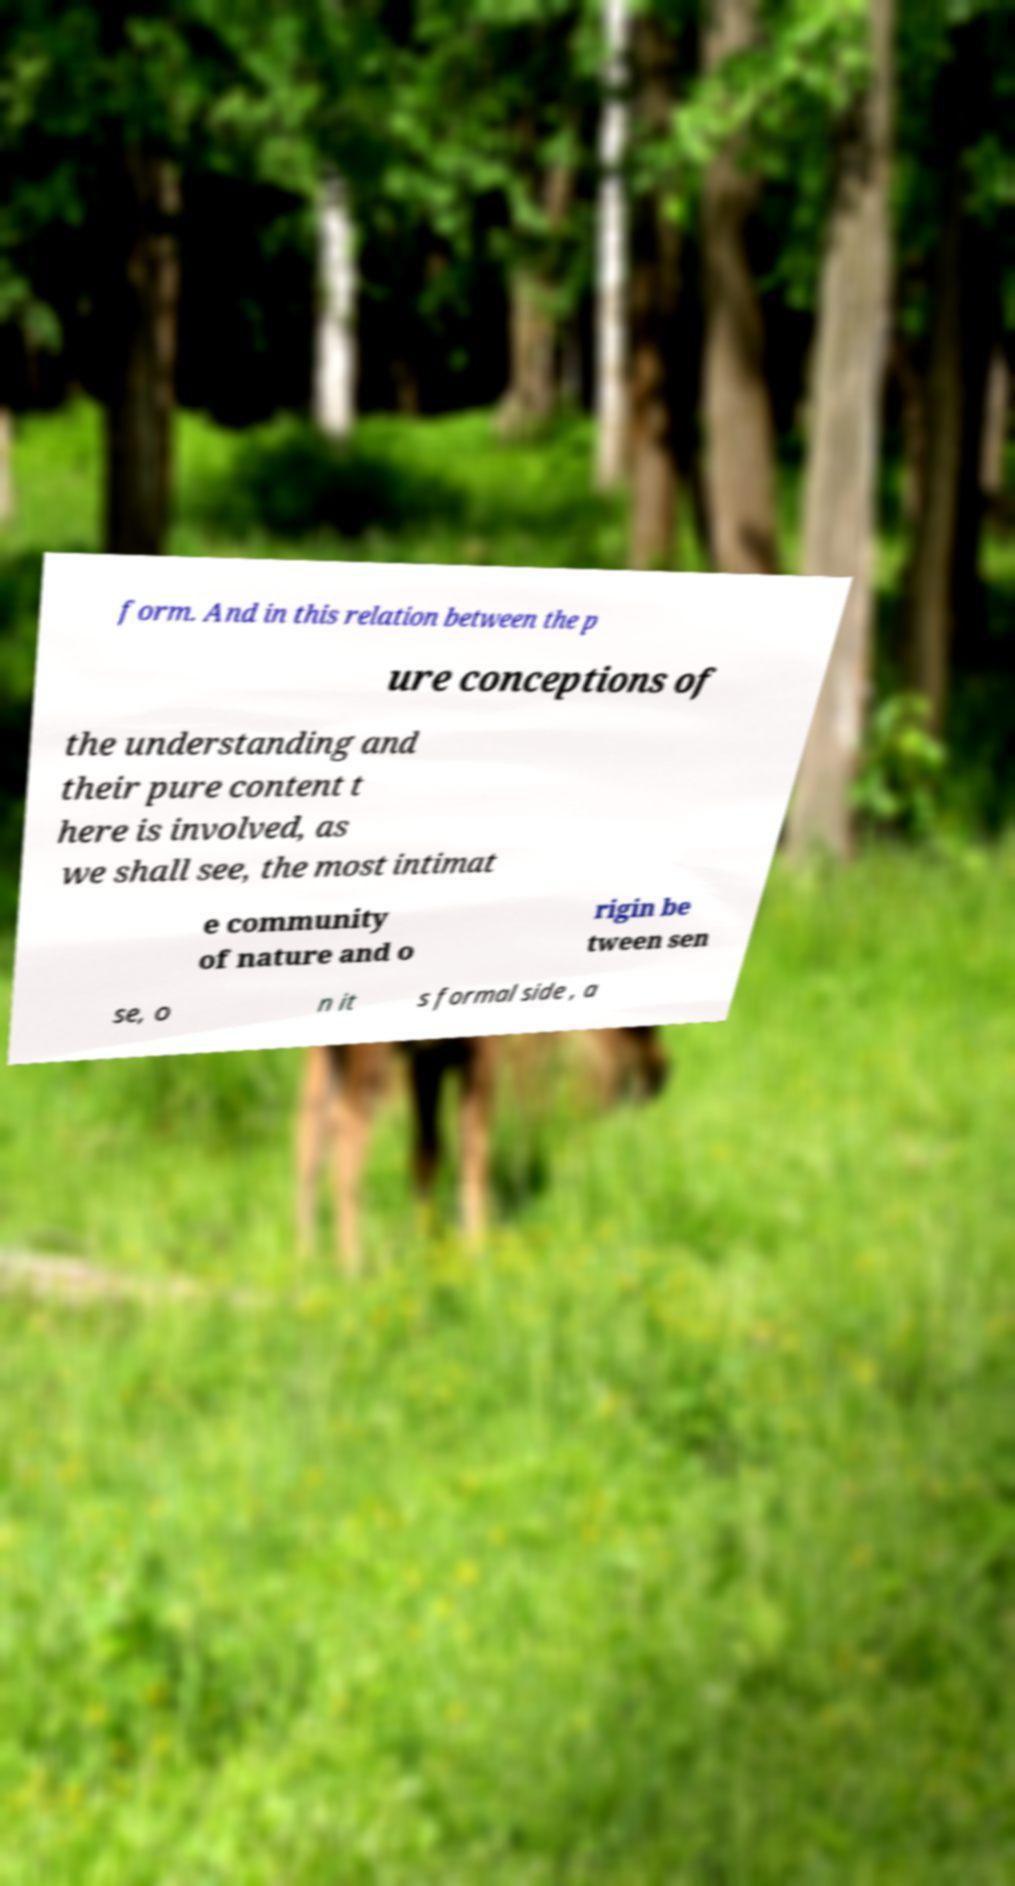Could you assist in decoding the text presented in this image and type it out clearly? form. And in this relation between the p ure conceptions of the understanding and their pure content t here is involved, as we shall see, the most intimat e community of nature and o rigin be tween sen se, o n it s formal side , a 